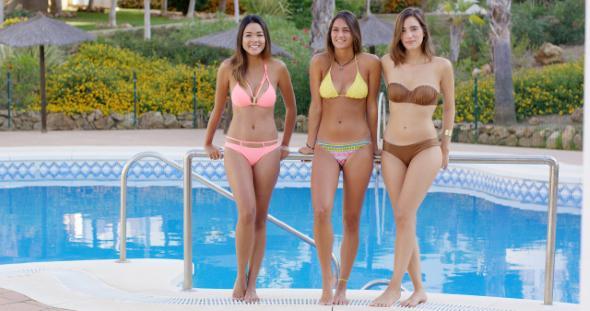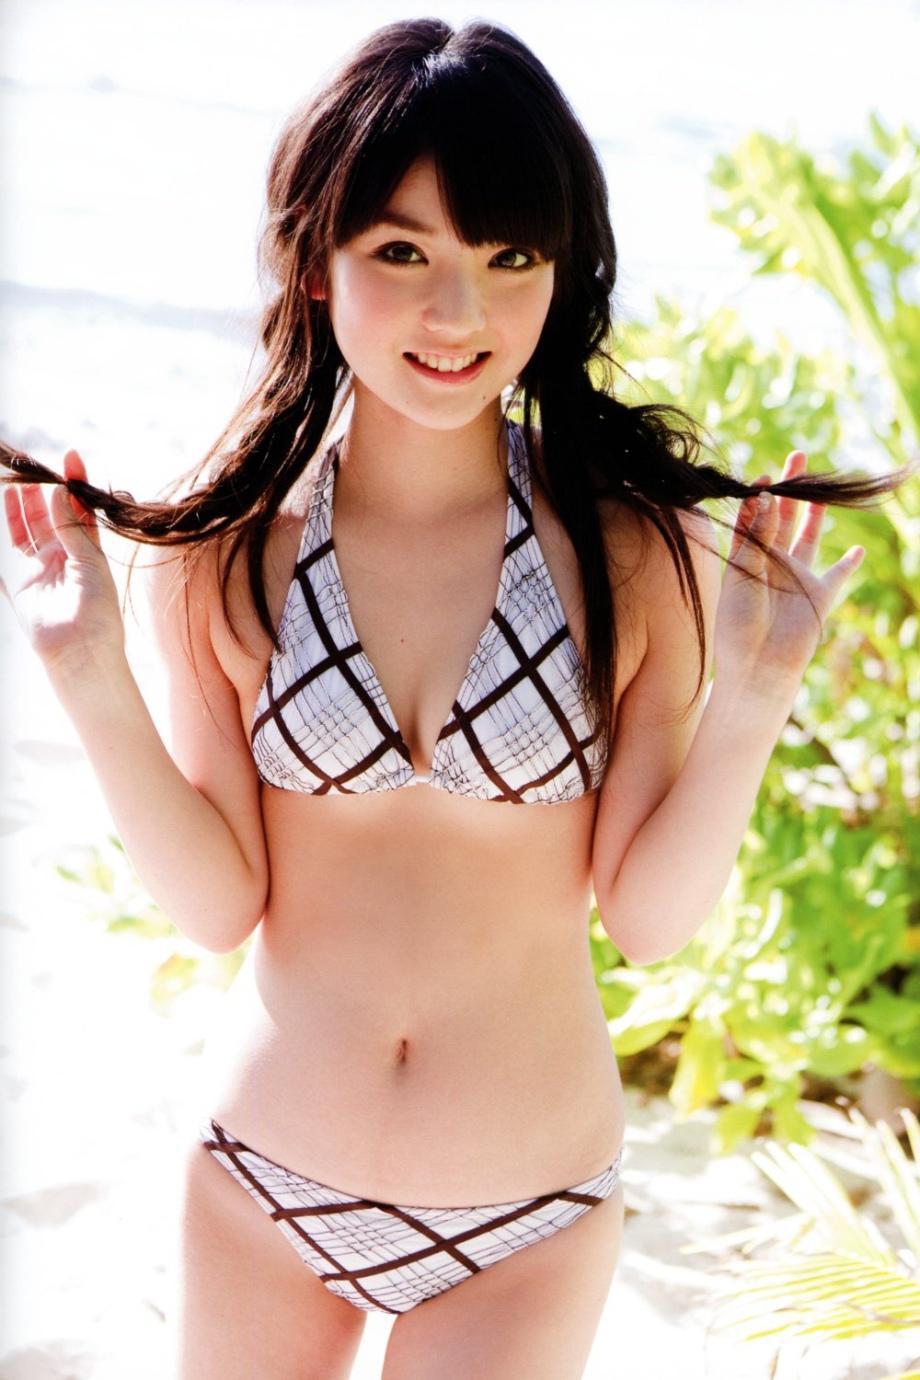The first image is the image on the left, the second image is the image on the right. Assess this claim about the two images: "Three camera-facing swimwear models stand side-by-side in front of a swimming pool.". Correct or not? Answer yes or no. Yes. The first image is the image on the left, the second image is the image on the right. Given the left and right images, does the statement "There are no more than three women." hold true? Answer yes or no. No. 